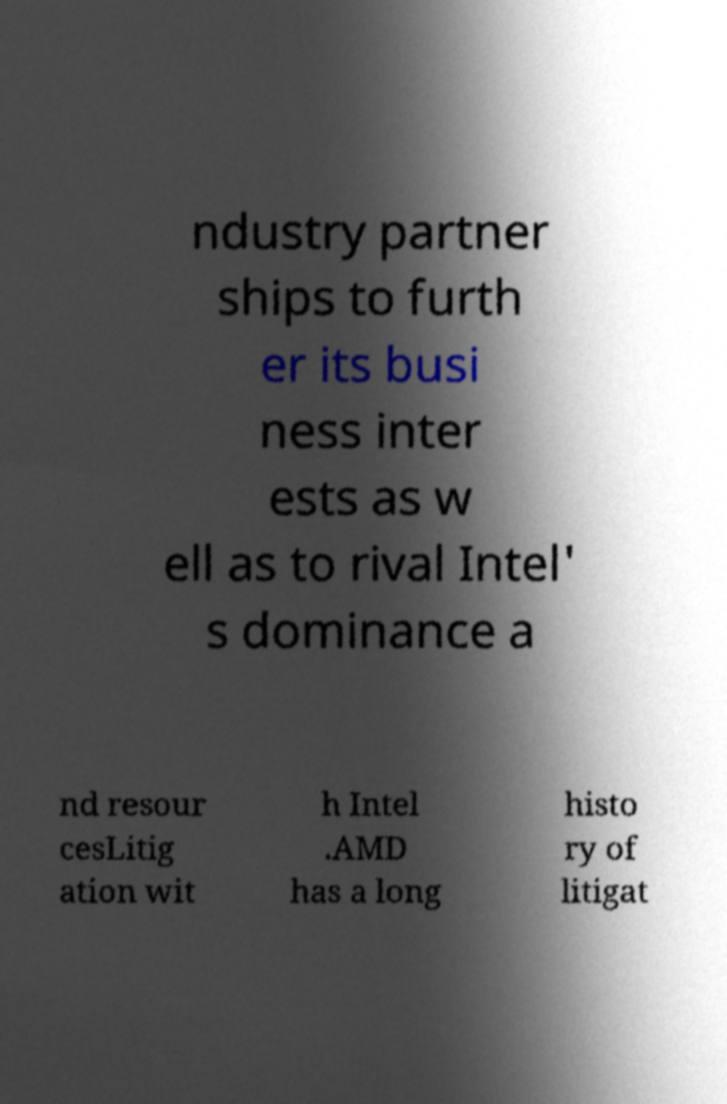Could you extract and type out the text from this image? ndustry partner ships to furth er its busi ness inter ests as w ell as to rival Intel' s dominance a nd resour cesLitig ation wit h Intel .AMD has a long histo ry of litigat 